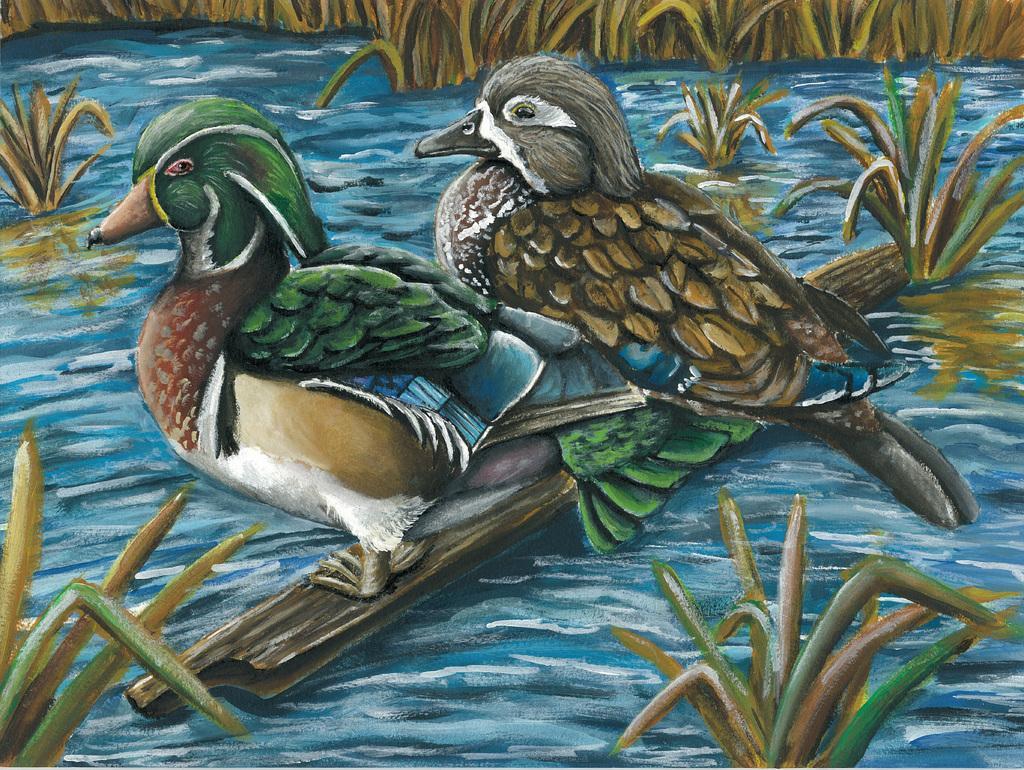Can you describe this image briefly? This image is a cartoon. In the center of the image there are two birds standing on the stick sailing on the river. In the background there are plants. 